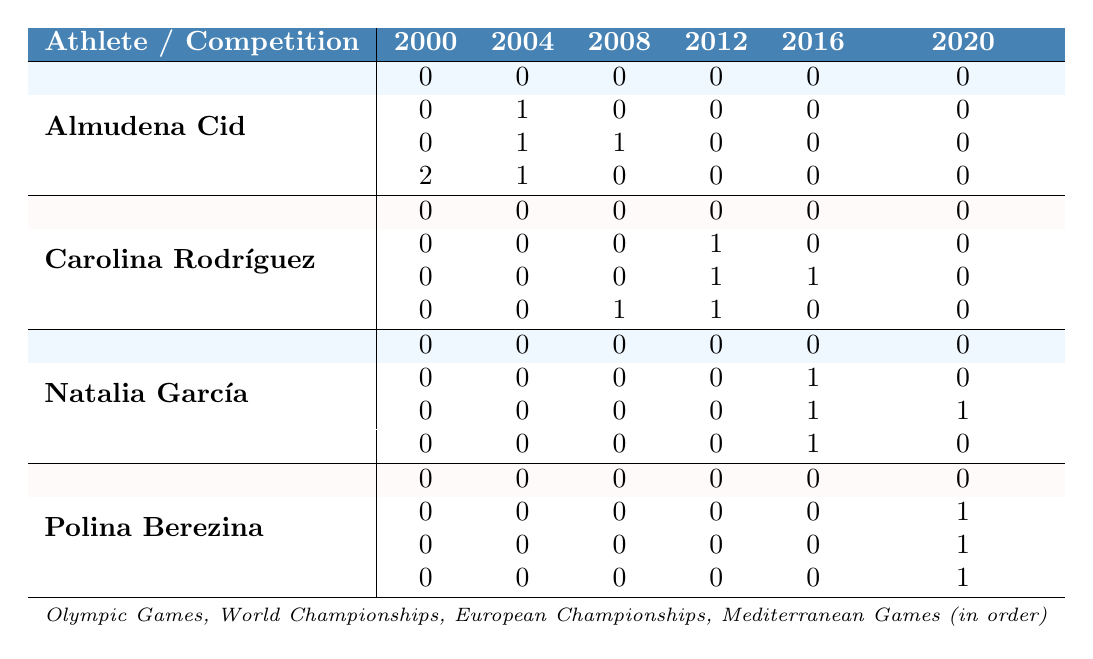What is the total number of medals won by Almudena Cid at the Mediterranean Games from 2000 to 2020? From the table, Almudena Cid's medal counts at the Mediterranean Games across the years are 2, 1, 0, 0, 0, and 0. Adding these together gives 2 + 1 + 0 + 0 + 0 + 0 = 3.
Answer: 3 Which athlete has the highest total medal count in the European Championships from 2000 to 2020? Examining the European Championships data for each athlete, Almudena Cid won 2 medals, Carolina Rodríguez won 2 medals, Natalia García won 2 medals, and Polina Berezina won 0 medals. Therefore, Almudena Cid, Carolina Rodríguez, and Natalia García all have the highest count, which is 2.
Answer: Almudena Cid, Carolina Rodríguez, and Natalia García (2 medals each) Did Carolina Rodríguez win any medals at the Olympic Games? Referring to the Olympic Games row for Carolina Rodríguez, the counts are all 0 across the years (2000 to 2020). Thus, she did not win any medals at the Olympic Games.
Answer: No How many medals did Natalia García win at the World Championships in total across the years? The World Championships data for Natalia García shows medal counts of 0, 0, 0, 0, 1, and 0 for the years 2000 to 2020. Summing these values results in 0 + 0 + 0 + 0 + 1 + 0 = 1 medal.
Answer: 1 In which year did Polina Berezina win her first medal in the Mediterranean Games? The Mediterranean Games data for Polina Berezina indicates 0 medals in all years except for 2020, where she won 1 medal. Thus, her first (and only) medal in the Mediterranean Games was in 2020.
Answer: 2020 What is the average number of medals won by Carolina Rodríguez at the European Championships between 2000 and 2020? The medal counts for Carolina Rodríguez at the European Championships are 0, 0, 0, 1, 1, and 0. Summing these gives 0 + 0 + 0 + 1 + 1 + 0 = 2. There are 6 years, so the average is 2 / 6 = 0.33.
Answer: 0.33 Which Spanish athlete achieved a medal count of 1 at the World Championships in 2012? Looking at the World Championships row for 2012, the only athlete who achieved this count is Carolina Rodríguez (1 medal).
Answer: Carolina Rodríguez How many total medals did all athletes win at the Mediterranean Games from 2000 to 2020? The total counts for each athlete at the Mediterranean Games are as follows: Almudena Cid (3), Carolina Rodríguez (2), Natalia García (1), and Polina Berezina (1). Adding these values gives 3 + 2 + 1 + 1 = 7 medals in total.
Answer: 7 Did any athletes win medals at the Olympic Games between 2000 and 2020? Evaluating the Olympic Games row for all athletes, each has a count of 0 throughout all the years listed. Therefore, no athlete won any medals at the Olympic Games during that period.
Answer: No What is the difference in the total number of medals won by Almudena Cid and Polina Berezina at the World Championships? For Almudena Cid, the total at the World Championships is 1 medal. For Polina Berezina, it is 1 medal as well. The difference is 1 - 1 = 0.
Answer: 0 